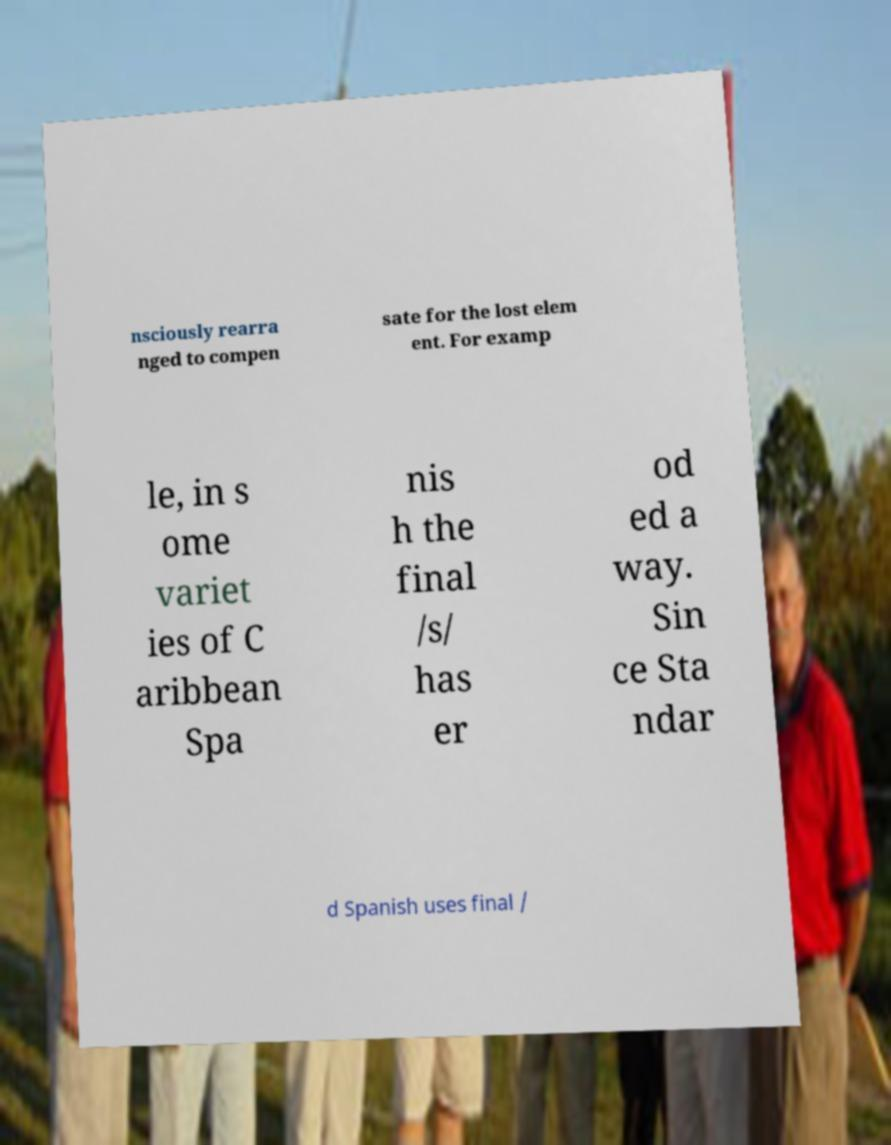I need the written content from this picture converted into text. Can you do that? nsciously rearra nged to compen sate for the lost elem ent. For examp le, in s ome variet ies of C aribbean Spa nis h the final /s/ has er od ed a way. Sin ce Sta ndar d Spanish uses final / 